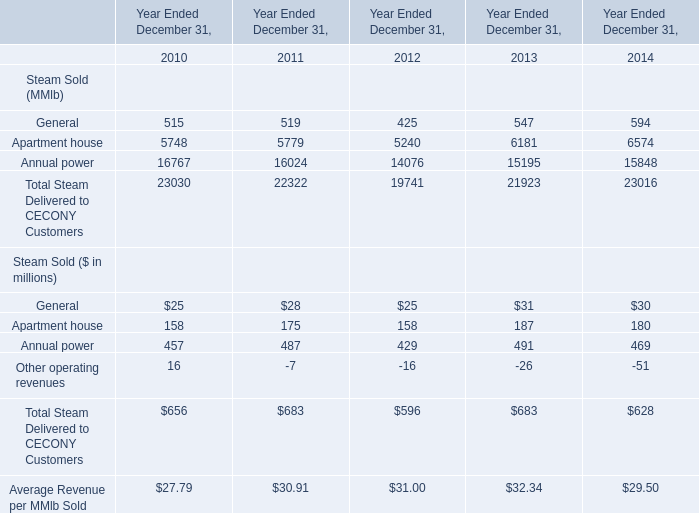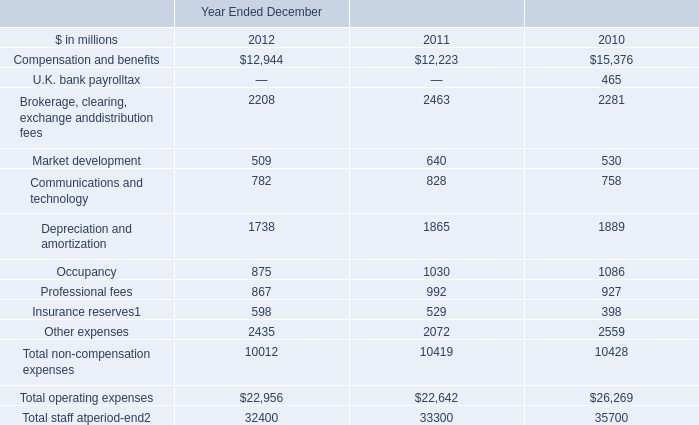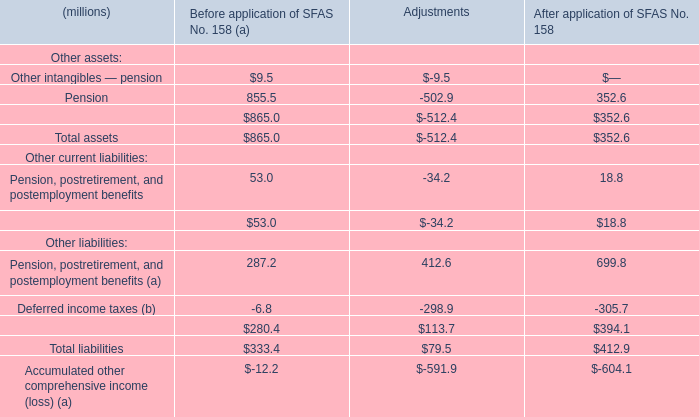What is the total amount of Brokerage, clearing, exchange anddistribution fees of Year Ended December 2011, Apartment house of Year Ended December 31, 2011, and Annual power of Year Ended December 31, 2011 ? 
Computations: ((2463.0 + 5779.0) + 16024.0)
Answer: 24266.0. 